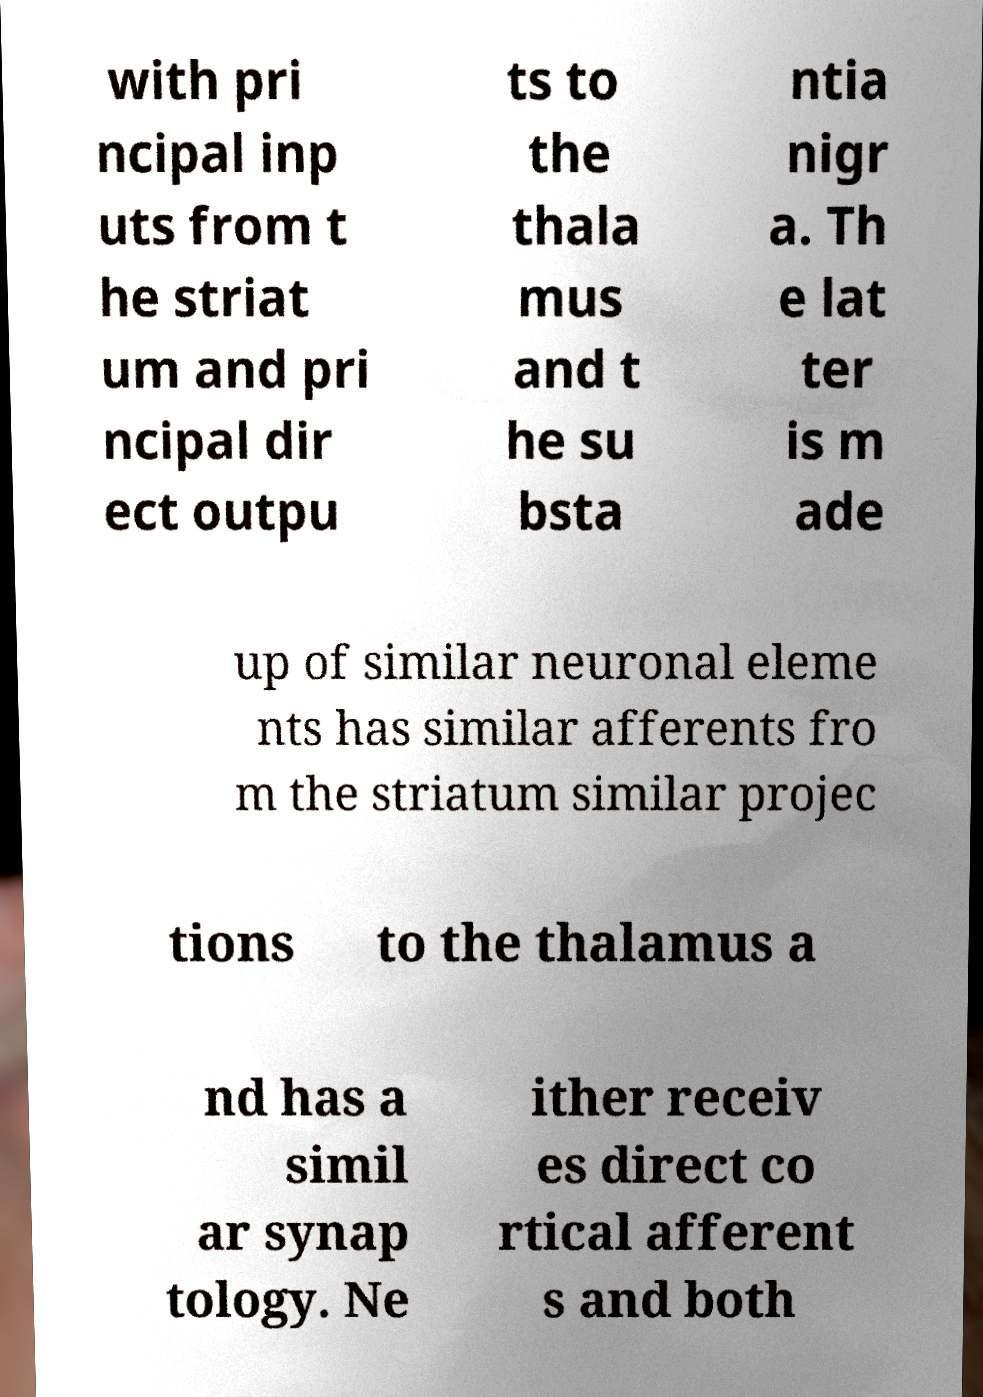Please identify and transcribe the text found in this image. with pri ncipal inp uts from t he striat um and pri ncipal dir ect outpu ts to the thala mus and t he su bsta ntia nigr a. Th e lat ter is m ade up of similar neuronal eleme nts has similar afferents fro m the striatum similar projec tions to the thalamus a nd has a simil ar synap tology. Ne ither receiv es direct co rtical afferent s and both 